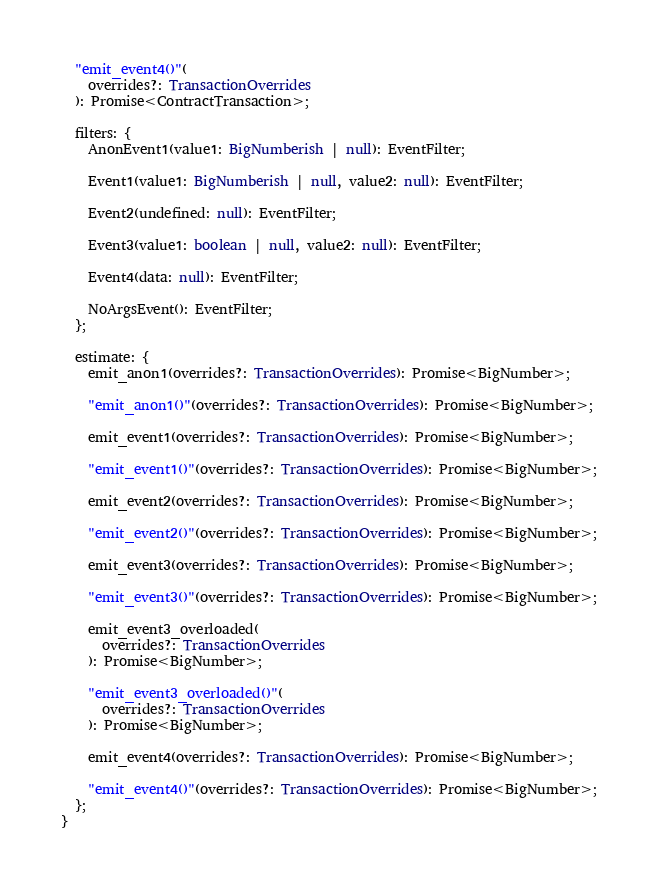Convert code to text. <code><loc_0><loc_0><loc_500><loc_500><_TypeScript_>  "emit_event4()"(
    overrides?: TransactionOverrides
  ): Promise<ContractTransaction>;

  filters: {
    AnonEvent1(value1: BigNumberish | null): EventFilter;

    Event1(value1: BigNumberish | null, value2: null): EventFilter;

    Event2(undefined: null): EventFilter;

    Event3(value1: boolean | null, value2: null): EventFilter;

    Event4(data: null): EventFilter;

    NoArgsEvent(): EventFilter;
  };

  estimate: {
    emit_anon1(overrides?: TransactionOverrides): Promise<BigNumber>;

    "emit_anon1()"(overrides?: TransactionOverrides): Promise<BigNumber>;

    emit_event1(overrides?: TransactionOverrides): Promise<BigNumber>;

    "emit_event1()"(overrides?: TransactionOverrides): Promise<BigNumber>;

    emit_event2(overrides?: TransactionOverrides): Promise<BigNumber>;

    "emit_event2()"(overrides?: TransactionOverrides): Promise<BigNumber>;

    emit_event3(overrides?: TransactionOverrides): Promise<BigNumber>;

    "emit_event3()"(overrides?: TransactionOverrides): Promise<BigNumber>;

    emit_event3_overloaded(
      overrides?: TransactionOverrides
    ): Promise<BigNumber>;

    "emit_event3_overloaded()"(
      overrides?: TransactionOverrides
    ): Promise<BigNumber>;

    emit_event4(overrides?: TransactionOverrides): Promise<BigNumber>;

    "emit_event4()"(overrides?: TransactionOverrides): Promise<BigNumber>;
  };
}
</code> 